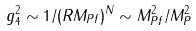<formula> <loc_0><loc_0><loc_500><loc_500>g _ { 4 } ^ { 2 } \sim 1 / ( R M _ { P f } ) ^ { N } \sim M _ { P f } ^ { 2 } / M _ { P } ^ { 2 }</formula> 